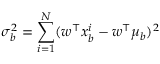Convert formula to latex. <formula><loc_0><loc_0><loc_500><loc_500>\sigma _ { b } ^ { 2 } = \sum _ { i = 1 } ^ { N } ( w ^ { \intercal } x _ { b } ^ { i } - w ^ { \intercal } \mu _ { b } ) ^ { 2 }</formula> 